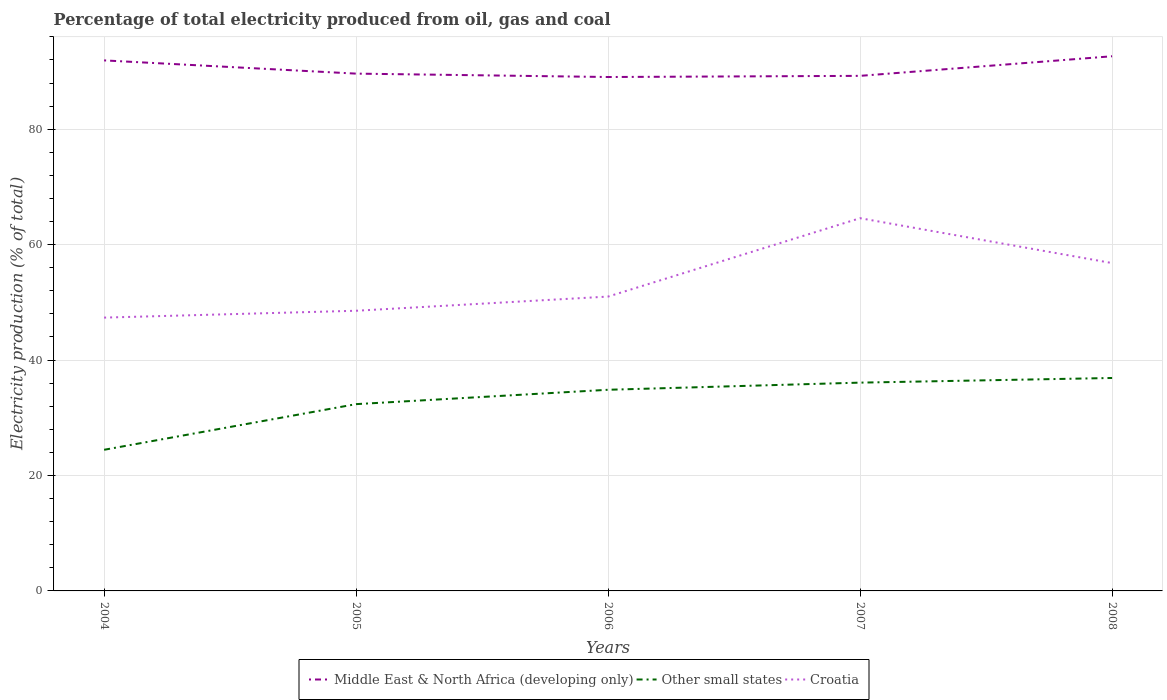How many different coloured lines are there?
Provide a succinct answer. 3. Across all years, what is the maximum electricity production in in Middle East & North Africa (developing only)?
Keep it short and to the point. 89.04. In which year was the electricity production in in Other small states maximum?
Make the answer very short. 2004. What is the total electricity production in in Croatia in the graph?
Give a very brief answer. -5.8. What is the difference between the highest and the second highest electricity production in in Middle East & North Africa (developing only)?
Make the answer very short. 3.6. Is the electricity production in in Other small states strictly greater than the electricity production in in Middle East & North Africa (developing only) over the years?
Your answer should be very brief. Yes. Where does the legend appear in the graph?
Give a very brief answer. Bottom center. How many legend labels are there?
Your response must be concise. 3. How are the legend labels stacked?
Ensure brevity in your answer.  Horizontal. What is the title of the graph?
Your answer should be compact. Percentage of total electricity produced from oil, gas and coal. What is the label or title of the Y-axis?
Your response must be concise. Electricity production (% of total). What is the Electricity production (% of total) of Middle East & North Africa (developing only) in 2004?
Make the answer very short. 91.92. What is the Electricity production (% of total) in Other small states in 2004?
Offer a very short reply. 24.45. What is the Electricity production (% of total) of Croatia in 2004?
Provide a short and direct response. 47.35. What is the Electricity production (% of total) in Middle East & North Africa (developing only) in 2005?
Offer a terse response. 89.63. What is the Electricity production (% of total) in Other small states in 2005?
Offer a very short reply. 32.36. What is the Electricity production (% of total) in Croatia in 2005?
Give a very brief answer. 48.54. What is the Electricity production (% of total) of Middle East & North Africa (developing only) in 2006?
Offer a terse response. 89.04. What is the Electricity production (% of total) in Other small states in 2006?
Ensure brevity in your answer.  34.85. What is the Electricity production (% of total) in Croatia in 2006?
Your answer should be very brief. 51. What is the Electricity production (% of total) in Middle East & North Africa (developing only) in 2007?
Make the answer very short. 89.24. What is the Electricity production (% of total) of Other small states in 2007?
Give a very brief answer. 36.09. What is the Electricity production (% of total) in Croatia in 2007?
Your response must be concise. 64.58. What is the Electricity production (% of total) of Middle East & North Africa (developing only) in 2008?
Your answer should be compact. 92.64. What is the Electricity production (% of total) in Other small states in 2008?
Your answer should be very brief. 36.89. What is the Electricity production (% of total) in Croatia in 2008?
Offer a terse response. 56.8. Across all years, what is the maximum Electricity production (% of total) of Middle East & North Africa (developing only)?
Make the answer very short. 92.64. Across all years, what is the maximum Electricity production (% of total) in Other small states?
Your response must be concise. 36.89. Across all years, what is the maximum Electricity production (% of total) of Croatia?
Make the answer very short. 64.58. Across all years, what is the minimum Electricity production (% of total) of Middle East & North Africa (developing only)?
Provide a succinct answer. 89.04. Across all years, what is the minimum Electricity production (% of total) in Other small states?
Ensure brevity in your answer.  24.45. Across all years, what is the minimum Electricity production (% of total) of Croatia?
Provide a succinct answer. 47.35. What is the total Electricity production (% of total) in Middle East & North Africa (developing only) in the graph?
Offer a terse response. 452.47. What is the total Electricity production (% of total) of Other small states in the graph?
Your answer should be very brief. 164.65. What is the total Electricity production (% of total) of Croatia in the graph?
Provide a short and direct response. 268.28. What is the difference between the Electricity production (% of total) in Middle East & North Africa (developing only) in 2004 and that in 2005?
Ensure brevity in your answer.  2.29. What is the difference between the Electricity production (% of total) of Other small states in 2004 and that in 2005?
Make the answer very short. -7.91. What is the difference between the Electricity production (% of total) in Croatia in 2004 and that in 2005?
Ensure brevity in your answer.  -1.19. What is the difference between the Electricity production (% of total) of Middle East & North Africa (developing only) in 2004 and that in 2006?
Your answer should be very brief. 2.88. What is the difference between the Electricity production (% of total) of Other small states in 2004 and that in 2006?
Keep it short and to the point. -10.4. What is the difference between the Electricity production (% of total) in Croatia in 2004 and that in 2006?
Offer a terse response. -3.65. What is the difference between the Electricity production (% of total) of Middle East & North Africa (developing only) in 2004 and that in 2007?
Offer a very short reply. 2.68. What is the difference between the Electricity production (% of total) of Other small states in 2004 and that in 2007?
Provide a short and direct response. -11.63. What is the difference between the Electricity production (% of total) in Croatia in 2004 and that in 2007?
Make the answer very short. -17.23. What is the difference between the Electricity production (% of total) of Middle East & North Africa (developing only) in 2004 and that in 2008?
Ensure brevity in your answer.  -0.72. What is the difference between the Electricity production (% of total) in Other small states in 2004 and that in 2008?
Your response must be concise. -12.44. What is the difference between the Electricity production (% of total) of Croatia in 2004 and that in 2008?
Provide a succinct answer. -9.45. What is the difference between the Electricity production (% of total) in Middle East & North Africa (developing only) in 2005 and that in 2006?
Offer a very short reply. 0.59. What is the difference between the Electricity production (% of total) in Other small states in 2005 and that in 2006?
Your answer should be very brief. -2.49. What is the difference between the Electricity production (% of total) in Croatia in 2005 and that in 2006?
Provide a short and direct response. -2.46. What is the difference between the Electricity production (% of total) in Middle East & North Africa (developing only) in 2005 and that in 2007?
Offer a terse response. 0.39. What is the difference between the Electricity production (% of total) of Other small states in 2005 and that in 2007?
Offer a very short reply. -3.73. What is the difference between the Electricity production (% of total) of Croatia in 2005 and that in 2007?
Ensure brevity in your answer.  -16.04. What is the difference between the Electricity production (% of total) of Middle East & North Africa (developing only) in 2005 and that in 2008?
Provide a short and direct response. -3.01. What is the difference between the Electricity production (% of total) in Other small states in 2005 and that in 2008?
Make the answer very short. -4.53. What is the difference between the Electricity production (% of total) in Croatia in 2005 and that in 2008?
Your answer should be compact. -8.26. What is the difference between the Electricity production (% of total) in Middle East & North Africa (developing only) in 2006 and that in 2007?
Your answer should be compact. -0.2. What is the difference between the Electricity production (% of total) of Other small states in 2006 and that in 2007?
Provide a short and direct response. -1.24. What is the difference between the Electricity production (% of total) of Croatia in 2006 and that in 2007?
Offer a very short reply. -13.58. What is the difference between the Electricity production (% of total) of Middle East & North Africa (developing only) in 2006 and that in 2008?
Offer a terse response. -3.6. What is the difference between the Electricity production (% of total) in Other small states in 2006 and that in 2008?
Make the answer very short. -2.04. What is the difference between the Electricity production (% of total) of Croatia in 2006 and that in 2008?
Provide a succinct answer. -5.8. What is the difference between the Electricity production (% of total) in Middle East & North Africa (developing only) in 2007 and that in 2008?
Keep it short and to the point. -3.4. What is the difference between the Electricity production (% of total) of Other small states in 2007 and that in 2008?
Your answer should be very brief. -0.81. What is the difference between the Electricity production (% of total) in Croatia in 2007 and that in 2008?
Your answer should be very brief. 7.78. What is the difference between the Electricity production (% of total) in Middle East & North Africa (developing only) in 2004 and the Electricity production (% of total) in Other small states in 2005?
Your answer should be very brief. 59.56. What is the difference between the Electricity production (% of total) of Middle East & North Africa (developing only) in 2004 and the Electricity production (% of total) of Croatia in 2005?
Ensure brevity in your answer.  43.38. What is the difference between the Electricity production (% of total) of Other small states in 2004 and the Electricity production (% of total) of Croatia in 2005?
Make the answer very short. -24.09. What is the difference between the Electricity production (% of total) in Middle East & North Africa (developing only) in 2004 and the Electricity production (% of total) in Other small states in 2006?
Provide a succinct answer. 57.07. What is the difference between the Electricity production (% of total) in Middle East & North Africa (developing only) in 2004 and the Electricity production (% of total) in Croatia in 2006?
Provide a short and direct response. 40.92. What is the difference between the Electricity production (% of total) of Other small states in 2004 and the Electricity production (% of total) of Croatia in 2006?
Offer a terse response. -26.55. What is the difference between the Electricity production (% of total) in Middle East & North Africa (developing only) in 2004 and the Electricity production (% of total) in Other small states in 2007?
Your answer should be compact. 55.83. What is the difference between the Electricity production (% of total) of Middle East & North Africa (developing only) in 2004 and the Electricity production (% of total) of Croatia in 2007?
Ensure brevity in your answer.  27.34. What is the difference between the Electricity production (% of total) in Other small states in 2004 and the Electricity production (% of total) in Croatia in 2007?
Ensure brevity in your answer.  -40.13. What is the difference between the Electricity production (% of total) in Middle East & North Africa (developing only) in 2004 and the Electricity production (% of total) in Other small states in 2008?
Ensure brevity in your answer.  55.02. What is the difference between the Electricity production (% of total) of Middle East & North Africa (developing only) in 2004 and the Electricity production (% of total) of Croatia in 2008?
Give a very brief answer. 35.12. What is the difference between the Electricity production (% of total) of Other small states in 2004 and the Electricity production (% of total) of Croatia in 2008?
Give a very brief answer. -32.35. What is the difference between the Electricity production (% of total) of Middle East & North Africa (developing only) in 2005 and the Electricity production (% of total) of Other small states in 2006?
Make the answer very short. 54.78. What is the difference between the Electricity production (% of total) of Middle East & North Africa (developing only) in 2005 and the Electricity production (% of total) of Croatia in 2006?
Provide a short and direct response. 38.63. What is the difference between the Electricity production (% of total) of Other small states in 2005 and the Electricity production (% of total) of Croatia in 2006?
Keep it short and to the point. -18.64. What is the difference between the Electricity production (% of total) in Middle East & North Africa (developing only) in 2005 and the Electricity production (% of total) in Other small states in 2007?
Make the answer very short. 53.54. What is the difference between the Electricity production (% of total) of Middle East & North Africa (developing only) in 2005 and the Electricity production (% of total) of Croatia in 2007?
Make the answer very short. 25.05. What is the difference between the Electricity production (% of total) in Other small states in 2005 and the Electricity production (% of total) in Croatia in 2007?
Your answer should be compact. -32.22. What is the difference between the Electricity production (% of total) in Middle East & North Africa (developing only) in 2005 and the Electricity production (% of total) in Other small states in 2008?
Provide a short and direct response. 52.73. What is the difference between the Electricity production (% of total) of Middle East & North Africa (developing only) in 2005 and the Electricity production (% of total) of Croatia in 2008?
Give a very brief answer. 32.82. What is the difference between the Electricity production (% of total) in Other small states in 2005 and the Electricity production (% of total) in Croatia in 2008?
Your answer should be compact. -24.44. What is the difference between the Electricity production (% of total) in Middle East & North Africa (developing only) in 2006 and the Electricity production (% of total) in Other small states in 2007?
Keep it short and to the point. 52.95. What is the difference between the Electricity production (% of total) of Middle East & North Africa (developing only) in 2006 and the Electricity production (% of total) of Croatia in 2007?
Provide a short and direct response. 24.46. What is the difference between the Electricity production (% of total) in Other small states in 2006 and the Electricity production (% of total) in Croatia in 2007?
Your answer should be very brief. -29.73. What is the difference between the Electricity production (% of total) in Middle East & North Africa (developing only) in 2006 and the Electricity production (% of total) in Other small states in 2008?
Offer a very short reply. 52.15. What is the difference between the Electricity production (% of total) in Middle East & North Africa (developing only) in 2006 and the Electricity production (% of total) in Croatia in 2008?
Offer a terse response. 32.24. What is the difference between the Electricity production (% of total) of Other small states in 2006 and the Electricity production (% of total) of Croatia in 2008?
Your answer should be very brief. -21.95. What is the difference between the Electricity production (% of total) of Middle East & North Africa (developing only) in 2007 and the Electricity production (% of total) of Other small states in 2008?
Offer a very short reply. 52.35. What is the difference between the Electricity production (% of total) in Middle East & North Africa (developing only) in 2007 and the Electricity production (% of total) in Croatia in 2008?
Offer a very short reply. 32.44. What is the difference between the Electricity production (% of total) of Other small states in 2007 and the Electricity production (% of total) of Croatia in 2008?
Your answer should be compact. -20.71. What is the average Electricity production (% of total) of Middle East & North Africa (developing only) per year?
Your response must be concise. 90.49. What is the average Electricity production (% of total) in Other small states per year?
Offer a terse response. 32.93. What is the average Electricity production (% of total) in Croatia per year?
Provide a succinct answer. 53.66. In the year 2004, what is the difference between the Electricity production (% of total) of Middle East & North Africa (developing only) and Electricity production (% of total) of Other small states?
Your answer should be very brief. 67.47. In the year 2004, what is the difference between the Electricity production (% of total) of Middle East & North Africa (developing only) and Electricity production (% of total) of Croatia?
Your answer should be very brief. 44.56. In the year 2004, what is the difference between the Electricity production (% of total) in Other small states and Electricity production (% of total) in Croatia?
Provide a short and direct response. -22.9. In the year 2005, what is the difference between the Electricity production (% of total) of Middle East & North Africa (developing only) and Electricity production (% of total) of Other small states?
Your response must be concise. 57.27. In the year 2005, what is the difference between the Electricity production (% of total) in Middle East & North Africa (developing only) and Electricity production (% of total) in Croatia?
Offer a terse response. 41.08. In the year 2005, what is the difference between the Electricity production (% of total) of Other small states and Electricity production (% of total) of Croatia?
Your answer should be compact. -16.18. In the year 2006, what is the difference between the Electricity production (% of total) in Middle East & North Africa (developing only) and Electricity production (% of total) in Other small states?
Offer a terse response. 54.19. In the year 2006, what is the difference between the Electricity production (% of total) of Middle East & North Africa (developing only) and Electricity production (% of total) of Croatia?
Your answer should be compact. 38.04. In the year 2006, what is the difference between the Electricity production (% of total) of Other small states and Electricity production (% of total) of Croatia?
Ensure brevity in your answer.  -16.15. In the year 2007, what is the difference between the Electricity production (% of total) in Middle East & North Africa (developing only) and Electricity production (% of total) in Other small states?
Your answer should be very brief. 53.15. In the year 2007, what is the difference between the Electricity production (% of total) in Middle East & North Africa (developing only) and Electricity production (% of total) in Croatia?
Your answer should be compact. 24.66. In the year 2007, what is the difference between the Electricity production (% of total) in Other small states and Electricity production (% of total) in Croatia?
Keep it short and to the point. -28.49. In the year 2008, what is the difference between the Electricity production (% of total) of Middle East & North Africa (developing only) and Electricity production (% of total) of Other small states?
Offer a very short reply. 55.74. In the year 2008, what is the difference between the Electricity production (% of total) of Middle East & North Africa (developing only) and Electricity production (% of total) of Croatia?
Provide a short and direct response. 35.83. In the year 2008, what is the difference between the Electricity production (% of total) of Other small states and Electricity production (% of total) of Croatia?
Offer a very short reply. -19.91. What is the ratio of the Electricity production (% of total) of Middle East & North Africa (developing only) in 2004 to that in 2005?
Make the answer very short. 1.03. What is the ratio of the Electricity production (% of total) in Other small states in 2004 to that in 2005?
Offer a very short reply. 0.76. What is the ratio of the Electricity production (% of total) of Croatia in 2004 to that in 2005?
Give a very brief answer. 0.98. What is the ratio of the Electricity production (% of total) in Middle East & North Africa (developing only) in 2004 to that in 2006?
Your response must be concise. 1.03. What is the ratio of the Electricity production (% of total) of Other small states in 2004 to that in 2006?
Give a very brief answer. 0.7. What is the ratio of the Electricity production (% of total) of Croatia in 2004 to that in 2006?
Offer a very short reply. 0.93. What is the ratio of the Electricity production (% of total) of Middle East & North Africa (developing only) in 2004 to that in 2007?
Keep it short and to the point. 1.03. What is the ratio of the Electricity production (% of total) in Other small states in 2004 to that in 2007?
Your answer should be compact. 0.68. What is the ratio of the Electricity production (% of total) of Croatia in 2004 to that in 2007?
Your response must be concise. 0.73. What is the ratio of the Electricity production (% of total) of Middle East & North Africa (developing only) in 2004 to that in 2008?
Keep it short and to the point. 0.99. What is the ratio of the Electricity production (% of total) in Other small states in 2004 to that in 2008?
Offer a very short reply. 0.66. What is the ratio of the Electricity production (% of total) of Croatia in 2004 to that in 2008?
Make the answer very short. 0.83. What is the ratio of the Electricity production (% of total) in Middle East & North Africa (developing only) in 2005 to that in 2006?
Provide a succinct answer. 1.01. What is the ratio of the Electricity production (% of total) of Other small states in 2005 to that in 2006?
Provide a short and direct response. 0.93. What is the ratio of the Electricity production (% of total) of Croatia in 2005 to that in 2006?
Make the answer very short. 0.95. What is the ratio of the Electricity production (% of total) in Other small states in 2005 to that in 2007?
Your response must be concise. 0.9. What is the ratio of the Electricity production (% of total) in Croatia in 2005 to that in 2007?
Your response must be concise. 0.75. What is the ratio of the Electricity production (% of total) in Middle East & North Africa (developing only) in 2005 to that in 2008?
Your response must be concise. 0.97. What is the ratio of the Electricity production (% of total) of Other small states in 2005 to that in 2008?
Keep it short and to the point. 0.88. What is the ratio of the Electricity production (% of total) of Croatia in 2005 to that in 2008?
Your response must be concise. 0.85. What is the ratio of the Electricity production (% of total) of Middle East & North Africa (developing only) in 2006 to that in 2007?
Your answer should be compact. 1. What is the ratio of the Electricity production (% of total) in Other small states in 2006 to that in 2007?
Your answer should be compact. 0.97. What is the ratio of the Electricity production (% of total) of Croatia in 2006 to that in 2007?
Give a very brief answer. 0.79. What is the ratio of the Electricity production (% of total) of Middle East & North Africa (developing only) in 2006 to that in 2008?
Your answer should be very brief. 0.96. What is the ratio of the Electricity production (% of total) in Other small states in 2006 to that in 2008?
Ensure brevity in your answer.  0.94. What is the ratio of the Electricity production (% of total) in Croatia in 2006 to that in 2008?
Offer a terse response. 0.9. What is the ratio of the Electricity production (% of total) in Middle East & North Africa (developing only) in 2007 to that in 2008?
Give a very brief answer. 0.96. What is the ratio of the Electricity production (% of total) in Other small states in 2007 to that in 2008?
Give a very brief answer. 0.98. What is the ratio of the Electricity production (% of total) of Croatia in 2007 to that in 2008?
Give a very brief answer. 1.14. What is the difference between the highest and the second highest Electricity production (% of total) in Middle East & North Africa (developing only)?
Keep it short and to the point. 0.72. What is the difference between the highest and the second highest Electricity production (% of total) of Other small states?
Make the answer very short. 0.81. What is the difference between the highest and the second highest Electricity production (% of total) in Croatia?
Your answer should be very brief. 7.78. What is the difference between the highest and the lowest Electricity production (% of total) in Middle East & North Africa (developing only)?
Provide a succinct answer. 3.6. What is the difference between the highest and the lowest Electricity production (% of total) in Other small states?
Provide a succinct answer. 12.44. What is the difference between the highest and the lowest Electricity production (% of total) of Croatia?
Offer a very short reply. 17.23. 